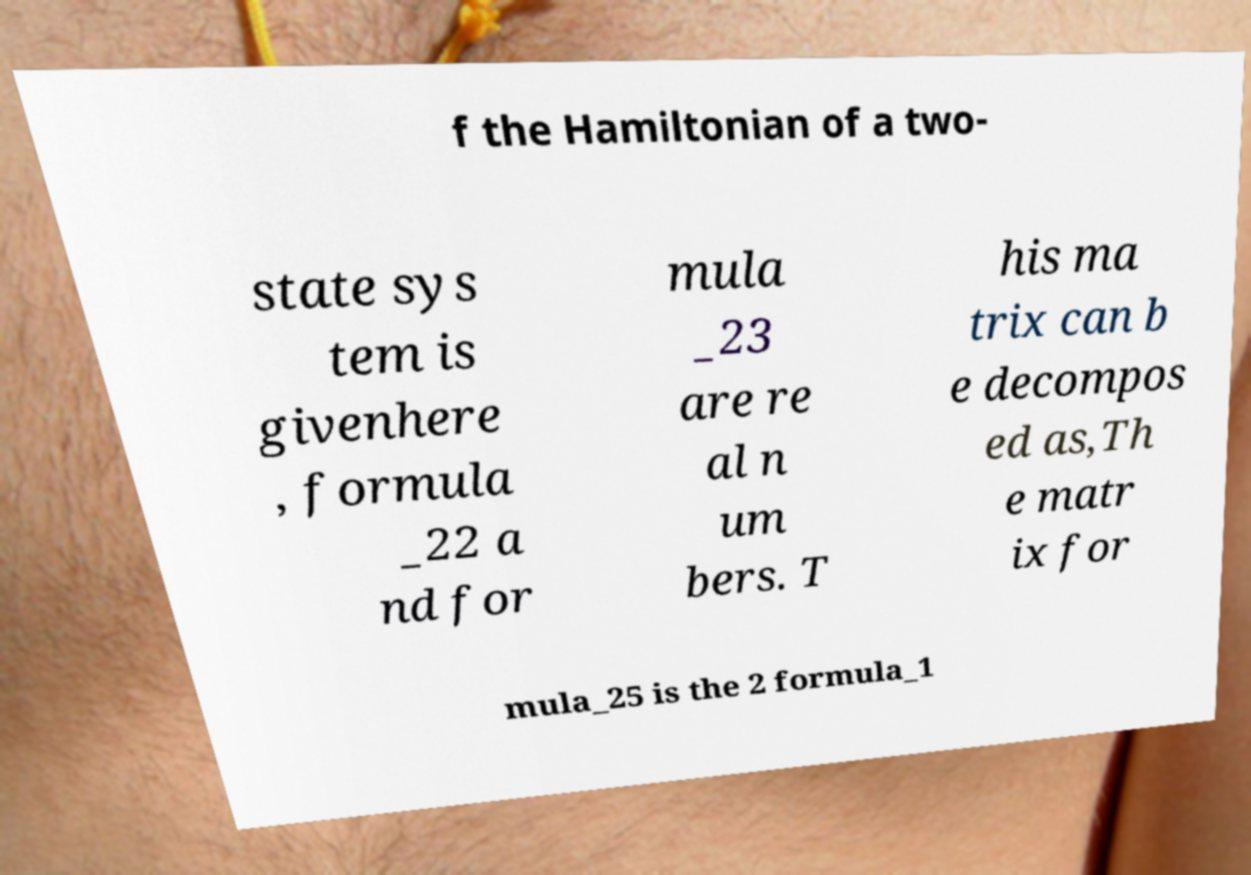I need the written content from this picture converted into text. Can you do that? f the Hamiltonian of a two- state sys tem is givenhere , formula _22 a nd for mula _23 are re al n um bers. T his ma trix can b e decompos ed as,Th e matr ix for mula_25 is the 2 formula_1 